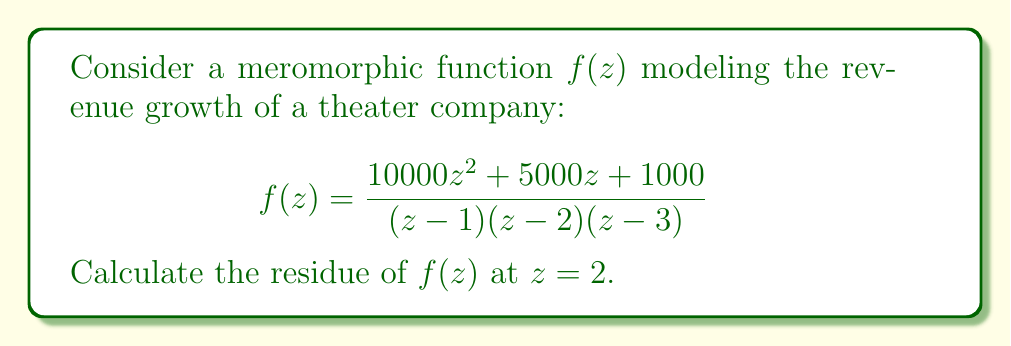Could you help me with this problem? To calculate the residue of $f(z)$ at $z=2$, we'll use the formula for the residue at a simple pole:

$$\text{Res}(f,a) = \lim_{z \to a} (z-a)f(z)$$

1) First, let's factor out $(z-2)$ from the denominator:

   $$f(z) = \frac{10000z^2 + 5000z + 1000}{(z-1)(z-2)(z-3)}$$

2) Now, we can rewrite $f(z)$ as:

   $$f(z) = \frac{g(z)}{(z-1)(z-3)}$$

   where $g(z) = \frac{10000z^2 + 5000z + 1000}{z-2}$

3) Apply the residue formula:

   $$\text{Res}(f,2) = \lim_{z \to 2} (z-2)f(z) = \lim_{z \to 2} \frac{g(z)}{(z-1)(z-3)}$$

4) Evaluate $g(2)$:

   $$g(2) = 10000(2)^2 + 5000(2) + 1000 = 40000 + 10000 + 1000 = 51000$$

5) Evaluate the denominator at $z=2$:

   $$(2-1)(2-3) = (1)(-1) = -1$$

6) Therefore, the residue is:

   $$\text{Res}(f,2) = \frac{51000}{-1} = -51000$$
Answer: The residue of $f(z)$ at $z=2$ is $-51000$. 